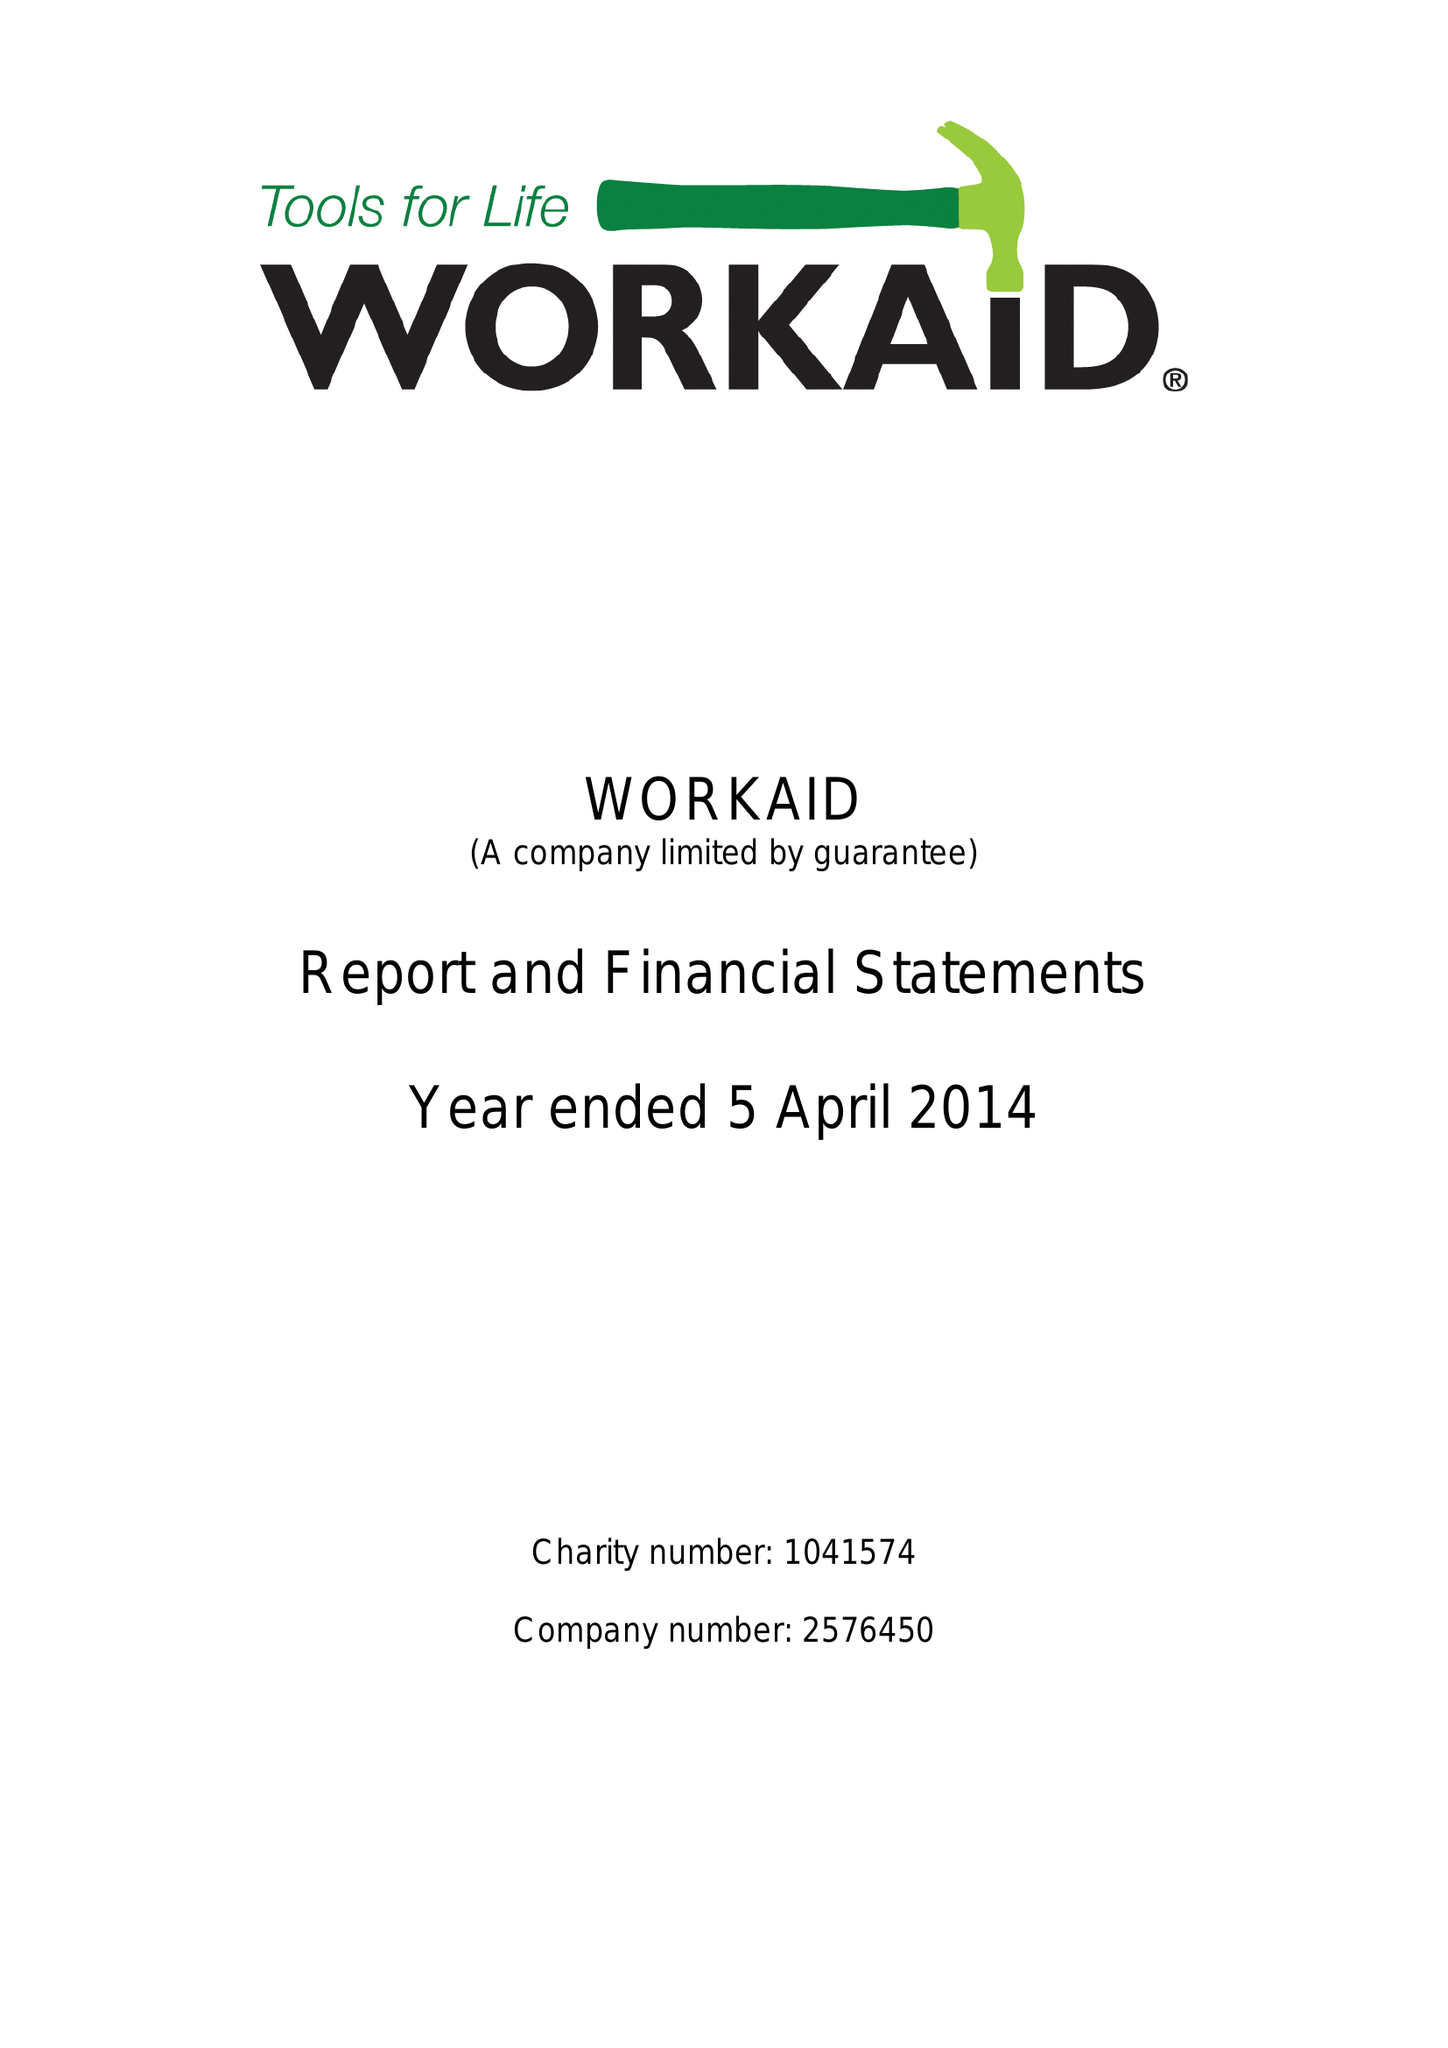What is the value for the address__postcode?
Answer the question using a single word or phrase. HP5 2AA 